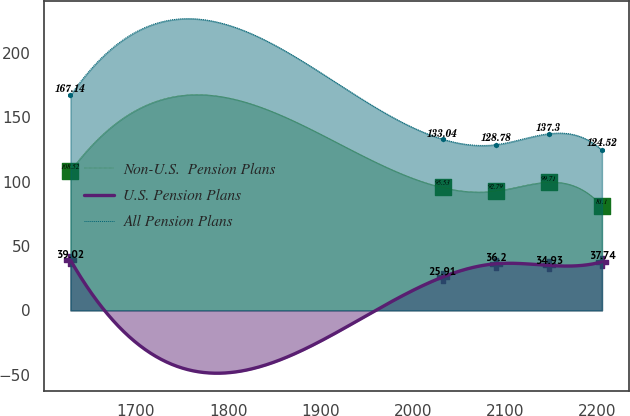<chart> <loc_0><loc_0><loc_500><loc_500><line_chart><ecel><fcel>Non-U.S.  Pension Plans<fcel>U.S. Pension Plans<fcel>All Pension Plans<nl><fcel>1629.07<fcel>108.52<fcel>39.02<fcel>167.14<nl><fcel>2032.23<fcel>95.53<fcel>25.91<fcel>133.04<nl><fcel>2089.73<fcel>92.79<fcel>36.2<fcel>128.78<nl><fcel>2147.23<fcel>99.71<fcel>34.93<fcel>137.3<nl><fcel>2204.73<fcel>81.1<fcel>37.74<fcel>124.52<nl></chart> 